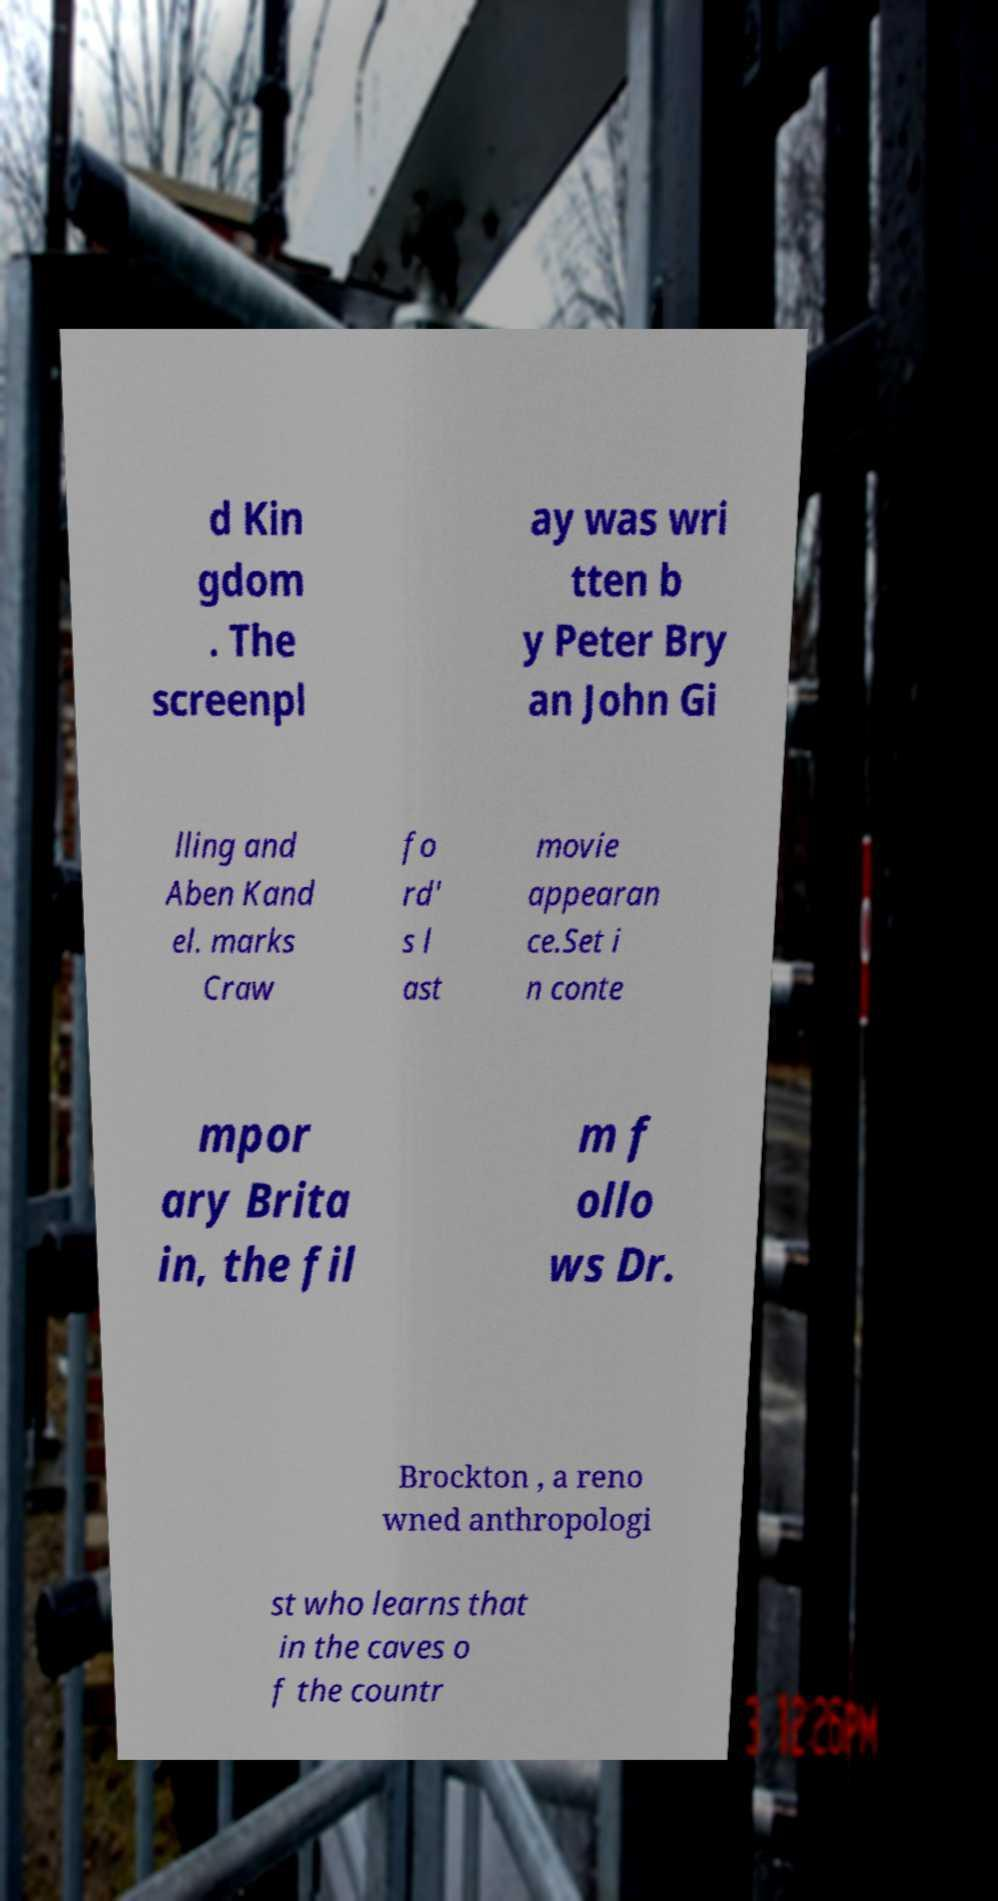There's text embedded in this image that I need extracted. Can you transcribe it verbatim? d Kin gdom . The screenpl ay was wri tten b y Peter Bry an John Gi lling and Aben Kand el. marks Craw fo rd' s l ast movie appearan ce.Set i n conte mpor ary Brita in, the fil m f ollo ws Dr. Brockton , a reno wned anthropologi st who learns that in the caves o f the countr 